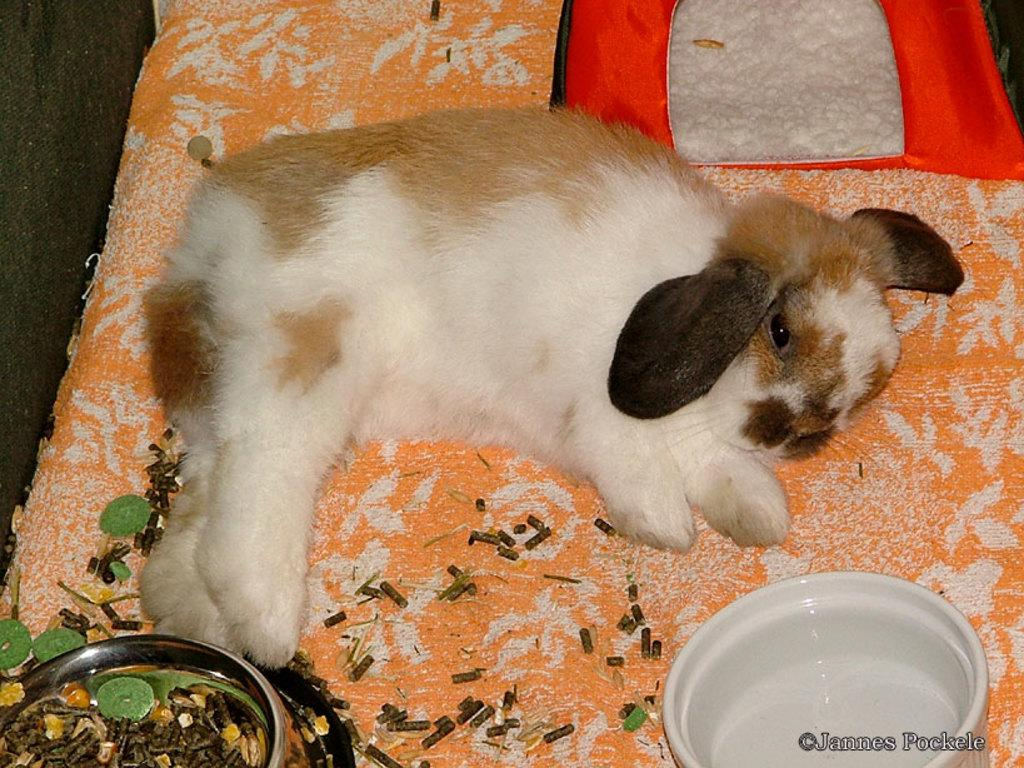What type of creature is in the image? There is an animal in the image. What is the animal doing in the image? The animal is sleeping. Can you describe the color of the animal? The animal has a white and brown color. What song is the animal singing in the image? The animal is sleeping in the image and not singing any song. 